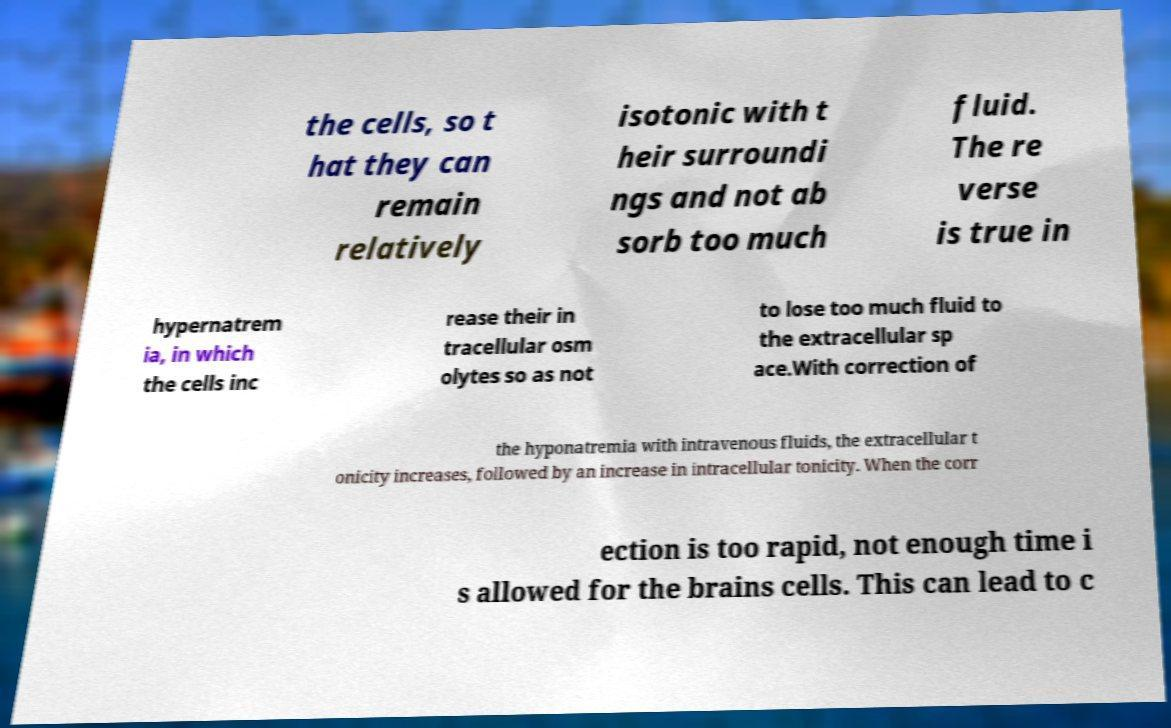Could you extract and type out the text from this image? the cells, so t hat they can remain relatively isotonic with t heir surroundi ngs and not ab sorb too much fluid. The re verse is true in hypernatrem ia, in which the cells inc rease their in tracellular osm olytes so as not to lose too much fluid to the extracellular sp ace.With correction of the hyponatremia with intravenous fluids, the extracellular t onicity increases, followed by an increase in intracellular tonicity. When the corr ection is too rapid, not enough time i s allowed for the brains cells. This can lead to c 